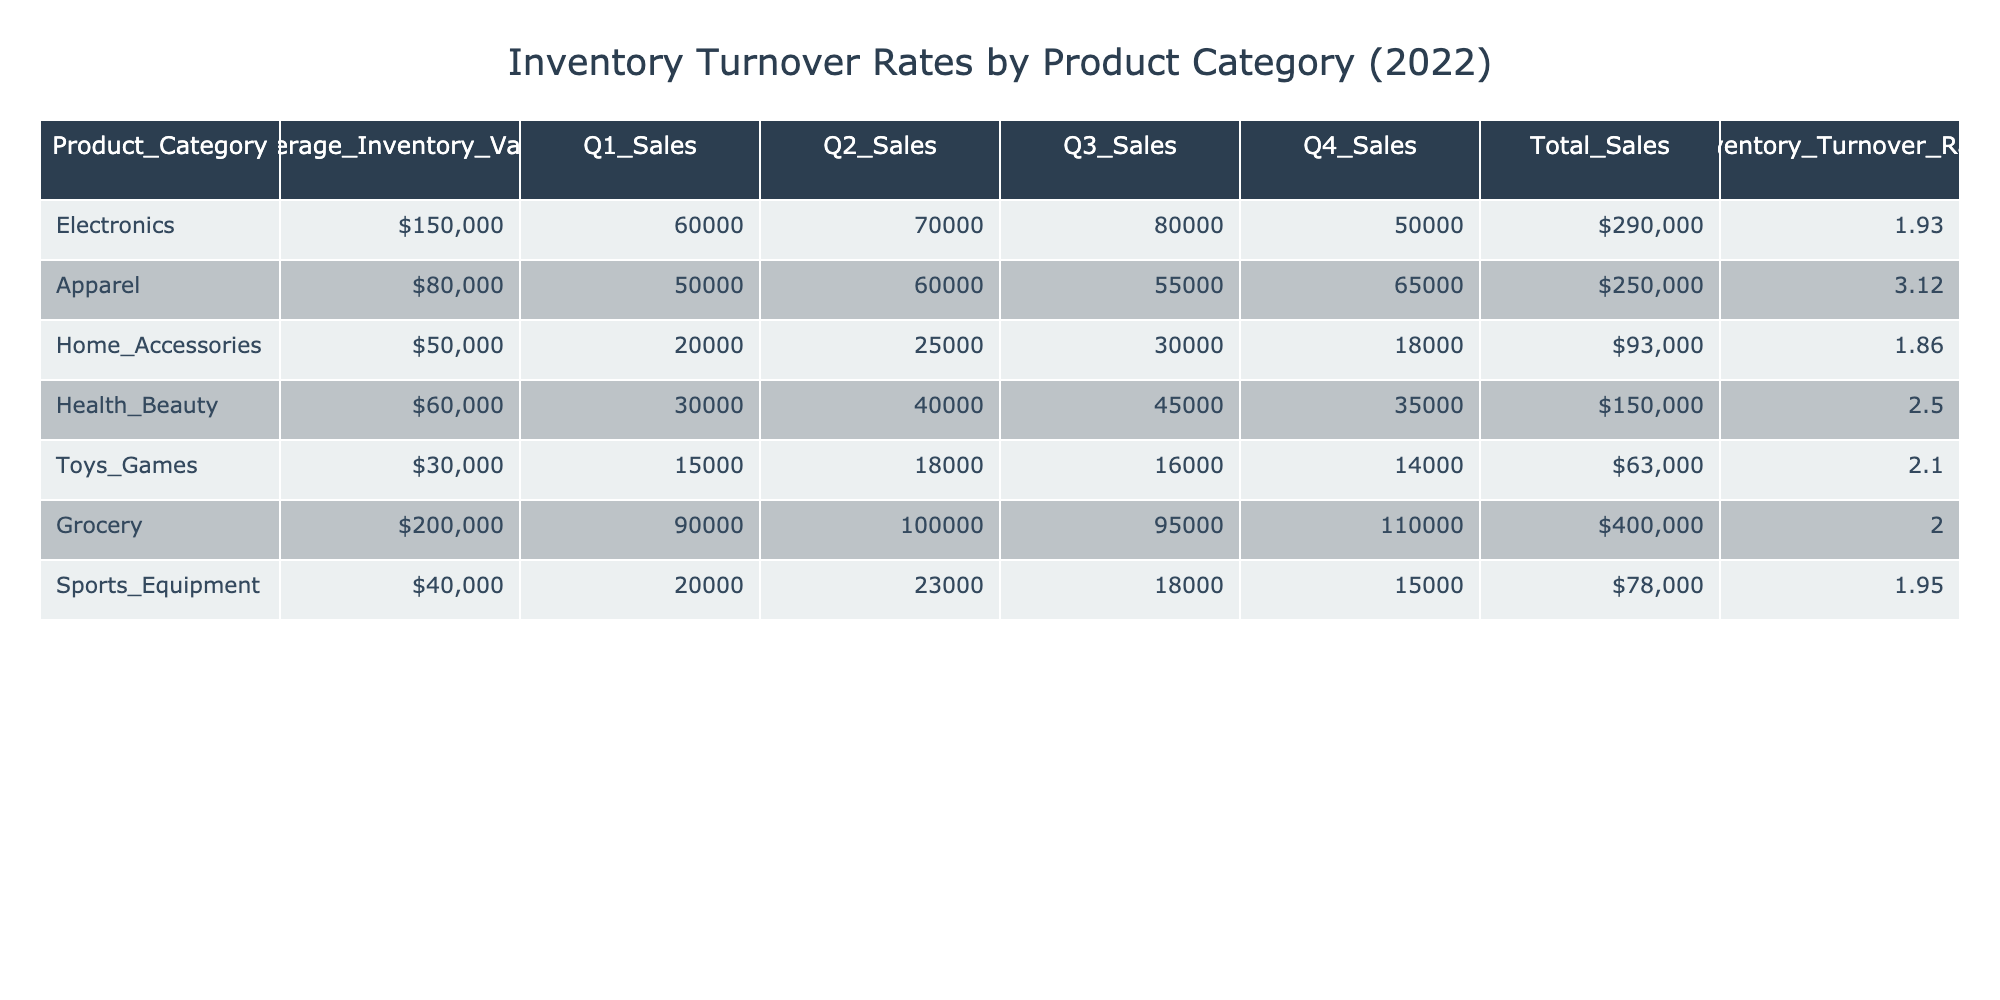What is the Inventory Turnover Rate for Apparel? The table provides the value for Inventory Turnover Rate directly under the Apparel category, which is 3.12.
Answer: 3.12 Which product category has the highest Average Inventory Value? Looking at the Average Inventory Value column, the Grocery category shows the highest value at $200,000 compared to others.
Answer: Grocery What is the Total Sales of Home Accessories? The Total Sales for the Home Accessories category can be found directly in the table, which is $93,000.
Answer: $93,000 Calculate the average Inventory Turnover Rate of Electronics and Toys Games. The Inventory Turnover Rate for Electronics is 1.93 and for Toys Games is 2.10. Adding these values: 1.93 + 2.10 = 4.03, then divide by 2 to get the average: 4.03 / 2 = 2.015.
Answer: 2.02 Is the Total Sales for Sports Equipment more than $80,000? The table lists the Total Sales for Sports Equipment as $78,000, which is less than $80,000.
Answer: No Which product category has the lowest Inventory Turnover Rate? By comparing the Inventory Turnover Rate for all categories, Home Accessories shows the lowest rate at 1.86.
Answer: Home Accessories What is the sum of the Average Inventory Values for Apparel and Health & Beauty? The Average Inventory Values are $80,000 for Apparel and $60,000 for Health & Beauty. Summing these gives $80,000 + $60,000 = $140,000.
Answer: $140,000 Does Grocery have a higher Total Sales than Electronics? The Total Sales for Grocery is $400,000, while Electronics has $290,000. Since $400,000 is greater than $290,000, the statement is true.
Answer: Yes Calculate the difference in Inventory Turnover Rates between Grocery and Apparel. The Inventory Turnover Rate for Grocery is 2.00 and for Apparel is 3.12. The difference is calculated as: 3.12 - 2.00 = 1.12.
Answer: 1.12 